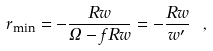Convert formula to latex. <formula><loc_0><loc_0><loc_500><loc_500>r _ { \min } = - \frac { R w } { \Omega - f R w } = - \frac { R w } { w ^ { \prime } } \ ,</formula> 